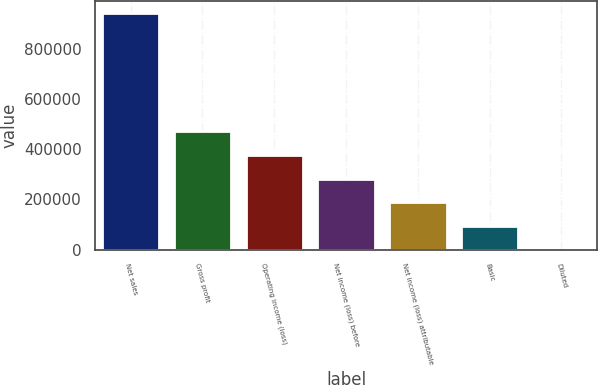Convert chart. <chart><loc_0><loc_0><loc_500><loc_500><bar_chart><fcel>Net sales<fcel>Gross profit<fcel>Operating income (loss)<fcel>Net income (loss) before<fcel>Net income (loss) attributable<fcel>Basic<fcel>Diluted<nl><fcel>941525<fcel>470763<fcel>376610<fcel>282458<fcel>188306<fcel>94153.1<fcel>0.72<nl></chart> 